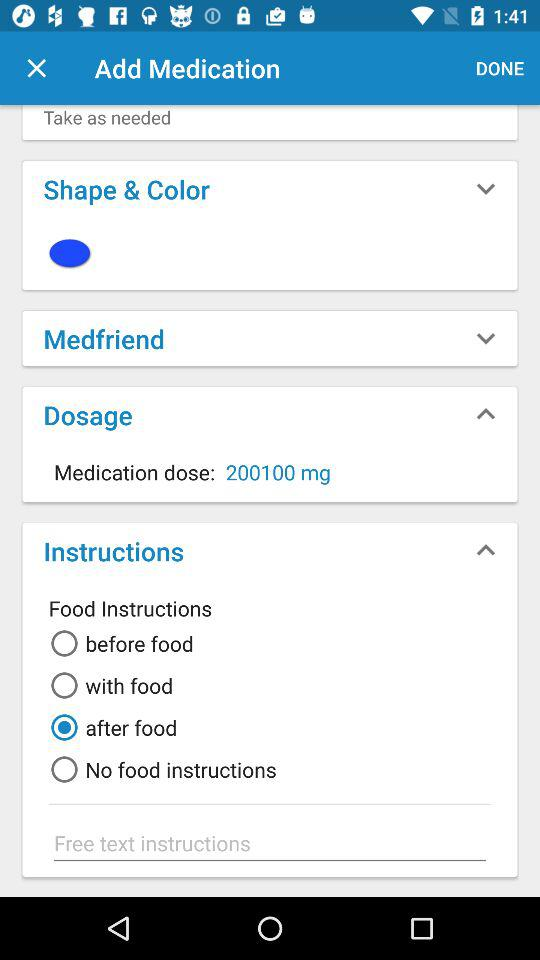What is the medication dose? The medication dose is 200100 milligrams. 